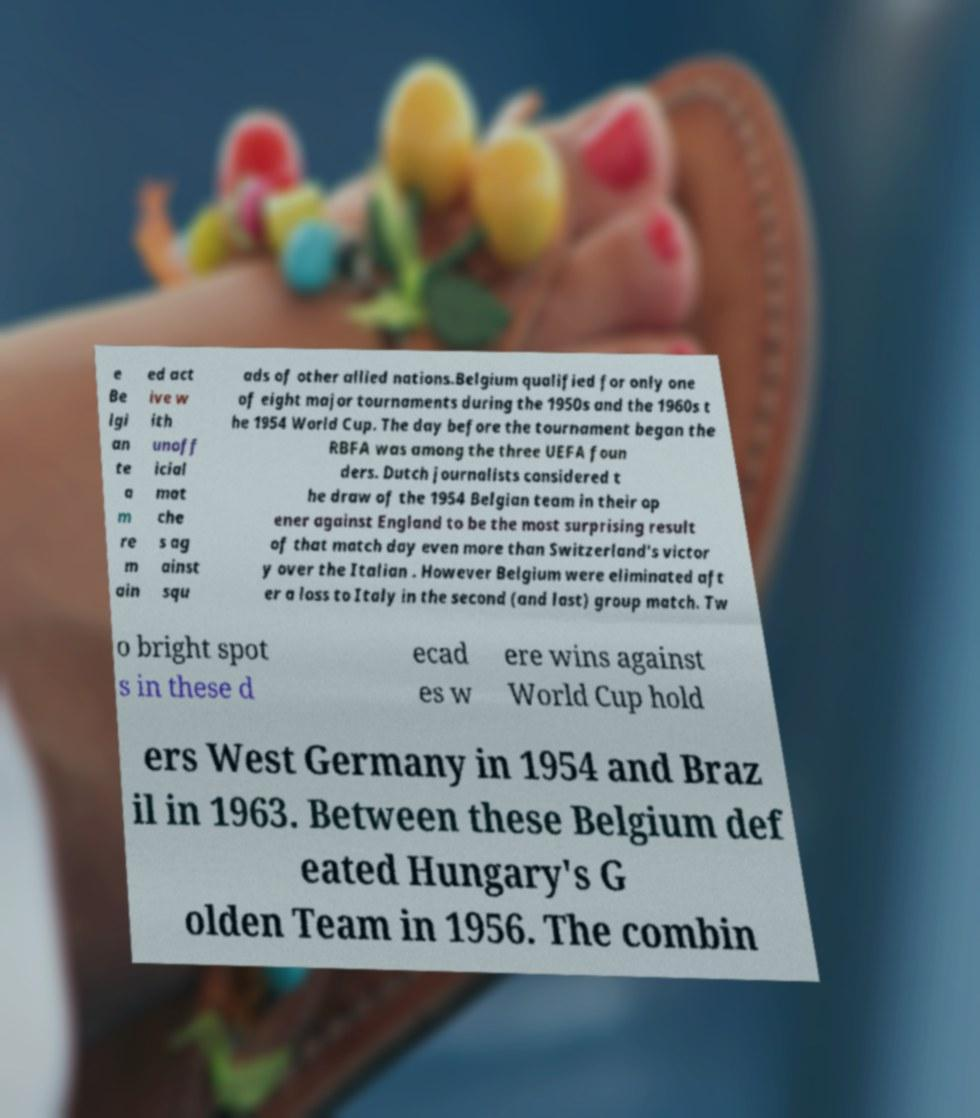Please read and relay the text visible in this image. What does it say? e Be lgi an te a m re m ain ed act ive w ith unoff icial mat che s ag ainst squ ads of other allied nations.Belgium qualified for only one of eight major tournaments during the 1950s and the 1960s t he 1954 World Cup. The day before the tournament began the RBFA was among the three UEFA foun ders. Dutch journalists considered t he draw of the 1954 Belgian team in their op ener against England to be the most surprising result of that match day even more than Switzerland's victor y over the Italian . However Belgium were eliminated aft er a loss to Italy in the second (and last) group match. Tw o bright spot s in these d ecad es w ere wins against World Cup hold ers West Germany in 1954 and Braz il in 1963. Between these Belgium def eated Hungary's G olden Team in 1956. The combin 